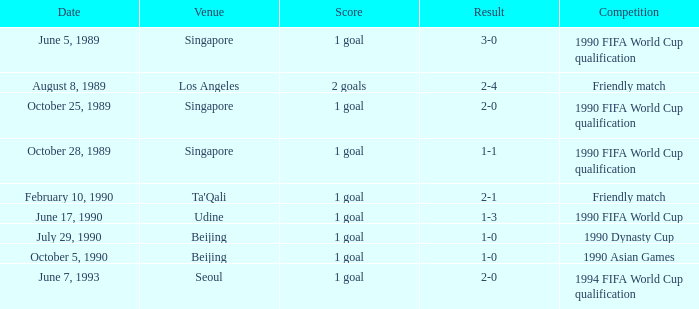Would you be able to parse every entry in this table? {'header': ['Date', 'Venue', 'Score', 'Result', 'Competition'], 'rows': [['June 5, 1989', 'Singapore', '1 goal', '3-0', '1990 FIFA World Cup qualification'], ['August 8, 1989', 'Los Angeles', '2 goals', '2-4', 'Friendly match'], ['October 25, 1989', 'Singapore', '1 goal', '2-0', '1990 FIFA World Cup qualification'], ['October 28, 1989', 'Singapore', '1 goal', '1-1', '1990 FIFA World Cup qualification'], ['February 10, 1990', "Ta'Qali", '1 goal', '2-1', 'Friendly match'], ['June 17, 1990', 'Udine', '1 goal', '1-3', '1990 FIFA World Cup'], ['July 29, 1990', 'Beijing', '1 goal', '1-0', '1990 Dynasty Cup'], ['October 5, 1990', 'Beijing', '1 goal', '1-0', '1990 Asian Games'], ['June 7, 1993', 'Seoul', '1 goal', '2-0', '1994 FIFA World Cup qualification']]} What is the venue of the 1990 Asian games? Beijing. 